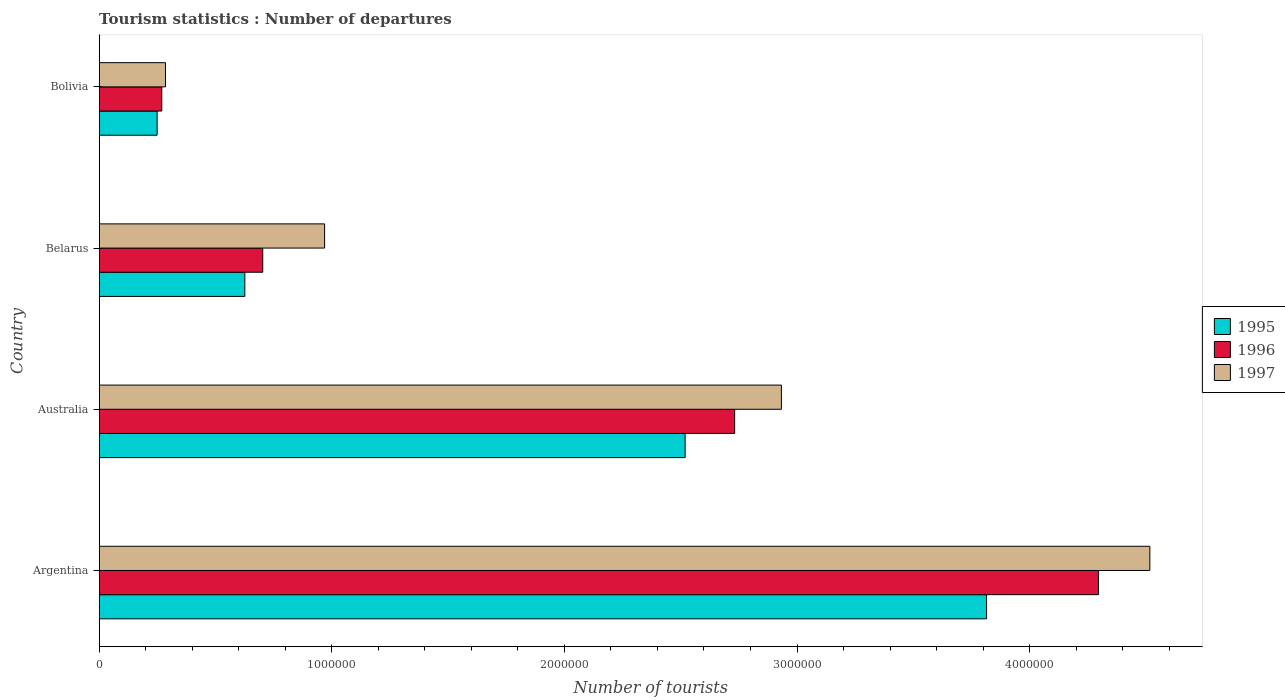How many different coloured bars are there?
Your response must be concise. 3. Are the number of bars on each tick of the Y-axis equal?
Provide a short and direct response. Yes. What is the label of the 2nd group of bars from the top?
Your answer should be compact. Belarus. What is the number of tourist departures in 1997 in Australia?
Give a very brief answer. 2.93e+06. Across all countries, what is the maximum number of tourist departures in 1997?
Provide a succinct answer. 4.52e+06. Across all countries, what is the minimum number of tourist departures in 1995?
Your answer should be very brief. 2.49e+05. In which country was the number of tourist departures in 1995 minimum?
Offer a very short reply. Bolivia. What is the difference between the number of tourist departures in 1995 in Argentina and that in Bolivia?
Keep it short and to the point. 3.57e+06. What is the difference between the number of tourist departures in 1996 in Argentina and the number of tourist departures in 1995 in Belarus?
Make the answer very short. 3.67e+06. What is the average number of tourist departures in 1995 per country?
Provide a short and direct response. 1.80e+06. What is the difference between the number of tourist departures in 1995 and number of tourist departures in 1996 in Argentina?
Your response must be concise. -4.81e+05. What is the ratio of the number of tourist departures in 1995 in Argentina to that in Australia?
Offer a very short reply. 1.51. Is the difference between the number of tourist departures in 1995 in Argentina and Australia greater than the difference between the number of tourist departures in 1996 in Argentina and Australia?
Offer a terse response. No. What is the difference between the highest and the second highest number of tourist departures in 1995?
Keep it short and to the point. 1.30e+06. What is the difference between the highest and the lowest number of tourist departures in 1997?
Make the answer very short. 4.23e+06. How many bars are there?
Give a very brief answer. 12. Are all the bars in the graph horizontal?
Offer a terse response. Yes. What is the difference between two consecutive major ticks on the X-axis?
Ensure brevity in your answer.  1.00e+06. How many legend labels are there?
Make the answer very short. 3. How are the legend labels stacked?
Provide a succinct answer. Vertical. What is the title of the graph?
Offer a very short reply. Tourism statistics : Number of departures. Does "2004" appear as one of the legend labels in the graph?
Your answer should be compact. No. What is the label or title of the X-axis?
Keep it short and to the point. Number of tourists. What is the Number of tourists of 1995 in Argentina?
Give a very brief answer. 3.82e+06. What is the Number of tourists in 1996 in Argentina?
Your answer should be compact. 4.30e+06. What is the Number of tourists in 1997 in Argentina?
Ensure brevity in your answer.  4.52e+06. What is the Number of tourists of 1995 in Australia?
Your answer should be compact. 2.52e+06. What is the Number of tourists of 1996 in Australia?
Ensure brevity in your answer.  2.73e+06. What is the Number of tourists in 1997 in Australia?
Offer a terse response. 2.93e+06. What is the Number of tourists of 1995 in Belarus?
Offer a very short reply. 6.26e+05. What is the Number of tourists of 1996 in Belarus?
Give a very brief answer. 7.03e+05. What is the Number of tourists in 1997 in Belarus?
Your answer should be very brief. 9.69e+05. What is the Number of tourists of 1995 in Bolivia?
Provide a short and direct response. 2.49e+05. What is the Number of tourists of 1996 in Bolivia?
Offer a terse response. 2.69e+05. What is the Number of tourists of 1997 in Bolivia?
Provide a short and direct response. 2.85e+05. Across all countries, what is the maximum Number of tourists of 1995?
Your answer should be compact. 3.82e+06. Across all countries, what is the maximum Number of tourists in 1996?
Offer a very short reply. 4.30e+06. Across all countries, what is the maximum Number of tourists of 1997?
Your response must be concise. 4.52e+06. Across all countries, what is the minimum Number of tourists of 1995?
Offer a terse response. 2.49e+05. Across all countries, what is the minimum Number of tourists of 1996?
Offer a terse response. 2.69e+05. Across all countries, what is the minimum Number of tourists of 1997?
Give a very brief answer. 2.85e+05. What is the total Number of tourists in 1995 in the graph?
Your answer should be very brief. 7.21e+06. What is the total Number of tourists in 1997 in the graph?
Offer a terse response. 8.70e+06. What is the difference between the Number of tourists in 1995 in Argentina and that in Australia?
Provide a succinct answer. 1.30e+06. What is the difference between the Number of tourists of 1996 in Argentina and that in Australia?
Provide a short and direct response. 1.56e+06. What is the difference between the Number of tourists in 1997 in Argentina and that in Australia?
Your response must be concise. 1.58e+06. What is the difference between the Number of tourists in 1995 in Argentina and that in Belarus?
Provide a succinct answer. 3.19e+06. What is the difference between the Number of tourists of 1996 in Argentina and that in Belarus?
Give a very brief answer. 3.59e+06. What is the difference between the Number of tourists of 1997 in Argentina and that in Belarus?
Your response must be concise. 3.55e+06. What is the difference between the Number of tourists in 1995 in Argentina and that in Bolivia?
Ensure brevity in your answer.  3.57e+06. What is the difference between the Number of tourists in 1996 in Argentina and that in Bolivia?
Your answer should be very brief. 4.03e+06. What is the difference between the Number of tourists of 1997 in Argentina and that in Bolivia?
Ensure brevity in your answer.  4.23e+06. What is the difference between the Number of tourists of 1995 in Australia and that in Belarus?
Offer a very short reply. 1.89e+06. What is the difference between the Number of tourists of 1996 in Australia and that in Belarus?
Your answer should be compact. 2.03e+06. What is the difference between the Number of tourists in 1997 in Australia and that in Belarus?
Provide a short and direct response. 1.96e+06. What is the difference between the Number of tourists of 1995 in Australia and that in Bolivia?
Offer a very short reply. 2.27e+06. What is the difference between the Number of tourists in 1996 in Australia and that in Bolivia?
Your answer should be compact. 2.46e+06. What is the difference between the Number of tourists in 1997 in Australia and that in Bolivia?
Provide a succinct answer. 2.65e+06. What is the difference between the Number of tourists of 1995 in Belarus and that in Bolivia?
Your answer should be very brief. 3.77e+05. What is the difference between the Number of tourists of 1996 in Belarus and that in Bolivia?
Make the answer very short. 4.34e+05. What is the difference between the Number of tourists of 1997 in Belarus and that in Bolivia?
Ensure brevity in your answer.  6.84e+05. What is the difference between the Number of tourists of 1995 in Argentina and the Number of tourists of 1996 in Australia?
Make the answer very short. 1.08e+06. What is the difference between the Number of tourists in 1995 in Argentina and the Number of tourists in 1997 in Australia?
Your answer should be compact. 8.82e+05. What is the difference between the Number of tourists of 1996 in Argentina and the Number of tourists of 1997 in Australia?
Provide a succinct answer. 1.36e+06. What is the difference between the Number of tourists of 1995 in Argentina and the Number of tourists of 1996 in Belarus?
Give a very brief answer. 3.11e+06. What is the difference between the Number of tourists in 1995 in Argentina and the Number of tourists in 1997 in Belarus?
Provide a succinct answer. 2.85e+06. What is the difference between the Number of tourists in 1996 in Argentina and the Number of tourists in 1997 in Belarus?
Provide a succinct answer. 3.33e+06. What is the difference between the Number of tourists of 1995 in Argentina and the Number of tourists of 1996 in Bolivia?
Offer a very short reply. 3.55e+06. What is the difference between the Number of tourists of 1995 in Argentina and the Number of tourists of 1997 in Bolivia?
Keep it short and to the point. 3.53e+06. What is the difference between the Number of tourists of 1996 in Argentina and the Number of tourists of 1997 in Bolivia?
Ensure brevity in your answer.  4.01e+06. What is the difference between the Number of tourists in 1995 in Australia and the Number of tourists in 1996 in Belarus?
Provide a succinct answer. 1.82e+06. What is the difference between the Number of tourists in 1995 in Australia and the Number of tourists in 1997 in Belarus?
Provide a succinct answer. 1.55e+06. What is the difference between the Number of tourists in 1996 in Australia and the Number of tourists in 1997 in Belarus?
Make the answer very short. 1.76e+06. What is the difference between the Number of tourists of 1995 in Australia and the Number of tourists of 1996 in Bolivia?
Your answer should be very brief. 2.25e+06. What is the difference between the Number of tourists of 1995 in Australia and the Number of tourists of 1997 in Bolivia?
Keep it short and to the point. 2.23e+06. What is the difference between the Number of tourists in 1996 in Australia and the Number of tourists in 1997 in Bolivia?
Keep it short and to the point. 2.45e+06. What is the difference between the Number of tourists in 1995 in Belarus and the Number of tourists in 1996 in Bolivia?
Provide a succinct answer. 3.57e+05. What is the difference between the Number of tourists in 1995 in Belarus and the Number of tourists in 1997 in Bolivia?
Provide a short and direct response. 3.41e+05. What is the difference between the Number of tourists in 1996 in Belarus and the Number of tourists in 1997 in Bolivia?
Give a very brief answer. 4.18e+05. What is the average Number of tourists of 1995 per country?
Provide a succinct answer. 1.80e+06. What is the average Number of tourists of 1997 per country?
Provide a succinct answer. 2.18e+06. What is the difference between the Number of tourists of 1995 and Number of tourists of 1996 in Argentina?
Your answer should be compact. -4.81e+05. What is the difference between the Number of tourists in 1995 and Number of tourists in 1997 in Argentina?
Ensure brevity in your answer.  -7.02e+05. What is the difference between the Number of tourists in 1996 and Number of tourists in 1997 in Argentina?
Provide a succinct answer. -2.21e+05. What is the difference between the Number of tourists of 1995 and Number of tourists of 1996 in Australia?
Offer a terse response. -2.13e+05. What is the difference between the Number of tourists of 1995 and Number of tourists of 1997 in Australia?
Provide a short and direct response. -4.14e+05. What is the difference between the Number of tourists of 1996 and Number of tourists of 1997 in Australia?
Keep it short and to the point. -2.01e+05. What is the difference between the Number of tourists in 1995 and Number of tourists in 1996 in Belarus?
Offer a very short reply. -7.70e+04. What is the difference between the Number of tourists in 1995 and Number of tourists in 1997 in Belarus?
Your response must be concise. -3.43e+05. What is the difference between the Number of tourists in 1996 and Number of tourists in 1997 in Belarus?
Offer a very short reply. -2.66e+05. What is the difference between the Number of tourists of 1995 and Number of tourists of 1997 in Bolivia?
Provide a succinct answer. -3.60e+04. What is the difference between the Number of tourists of 1996 and Number of tourists of 1997 in Bolivia?
Ensure brevity in your answer.  -1.60e+04. What is the ratio of the Number of tourists of 1995 in Argentina to that in Australia?
Make the answer very short. 1.51. What is the ratio of the Number of tourists of 1996 in Argentina to that in Australia?
Provide a succinct answer. 1.57. What is the ratio of the Number of tourists of 1997 in Argentina to that in Australia?
Give a very brief answer. 1.54. What is the ratio of the Number of tourists of 1995 in Argentina to that in Belarus?
Your answer should be compact. 6.09. What is the ratio of the Number of tourists of 1996 in Argentina to that in Belarus?
Offer a terse response. 6.11. What is the ratio of the Number of tourists in 1997 in Argentina to that in Belarus?
Offer a very short reply. 4.66. What is the ratio of the Number of tourists in 1995 in Argentina to that in Bolivia?
Provide a succinct answer. 15.32. What is the ratio of the Number of tourists of 1996 in Argentina to that in Bolivia?
Give a very brief answer. 15.97. What is the ratio of the Number of tourists of 1997 in Argentina to that in Bolivia?
Your response must be concise. 15.85. What is the ratio of the Number of tourists in 1995 in Australia to that in Belarus?
Ensure brevity in your answer.  4.02. What is the ratio of the Number of tourists in 1996 in Australia to that in Belarus?
Offer a very short reply. 3.89. What is the ratio of the Number of tourists in 1997 in Australia to that in Belarus?
Your answer should be compact. 3.03. What is the ratio of the Number of tourists in 1995 in Australia to that in Bolivia?
Keep it short and to the point. 10.12. What is the ratio of the Number of tourists of 1996 in Australia to that in Bolivia?
Offer a very short reply. 10.16. What is the ratio of the Number of tourists of 1997 in Australia to that in Bolivia?
Provide a succinct answer. 10.29. What is the ratio of the Number of tourists of 1995 in Belarus to that in Bolivia?
Provide a succinct answer. 2.51. What is the ratio of the Number of tourists of 1996 in Belarus to that in Bolivia?
Offer a terse response. 2.61. What is the ratio of the Number of tourists in 1997 in Belarus to that in Bolivia?
Offer a very short reply. 3.4. What is the difference between the highest and the second highest Number of tourists in 1995?
Make the answer very short. 1.30e+06. What is the difference between the highest and the second highest Number of tourists of 1996?
Keep it short and to the point. 1.56e+06. What is the difference between the highest and the second highest Number of tourists in 1997?
Offer a very short reply. 1.58e+06. What is the difference between the highest and the lowest Number of tourists in 1995?
Your response must be concise. 3.57e+06. What is the difference between the highest and the lowest Number of tourists of 1996?
Provide a succinct answer. 4.03e+06. What is the difference between the highest and the lowest Number of tourists of 1997?
Offer a very short reply. 4.23e+06. 